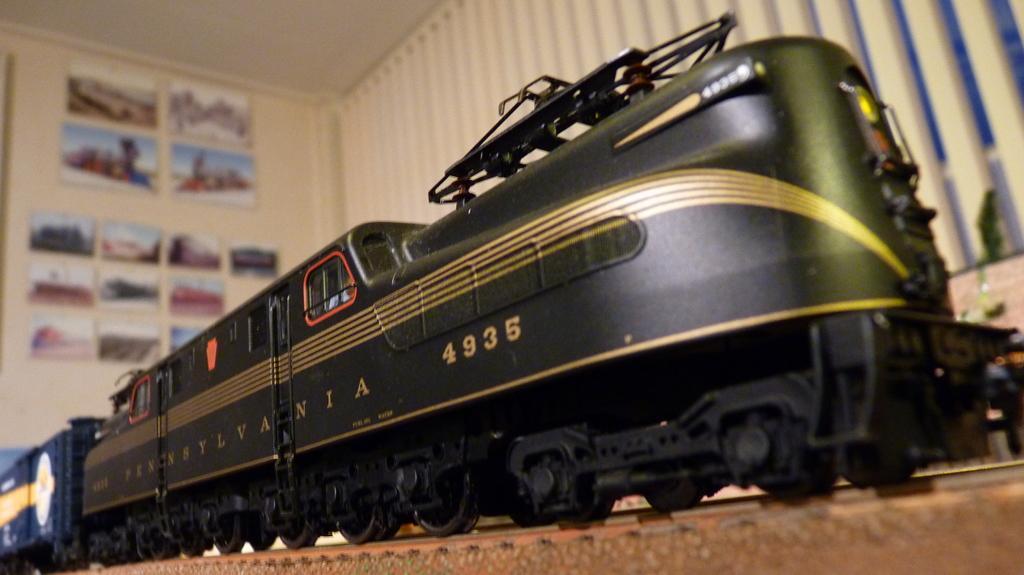Could you give a brief overview of what you see in this image? In the foreground of this image, there is a toy train and in the background, there are frames on the wall. 